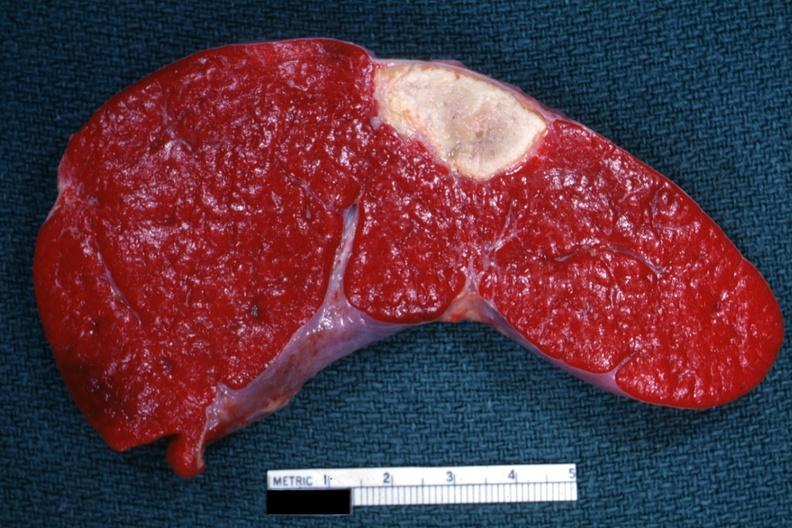s metastatic malignant melanoma present?
Answer the question using a single word or phrase. No 